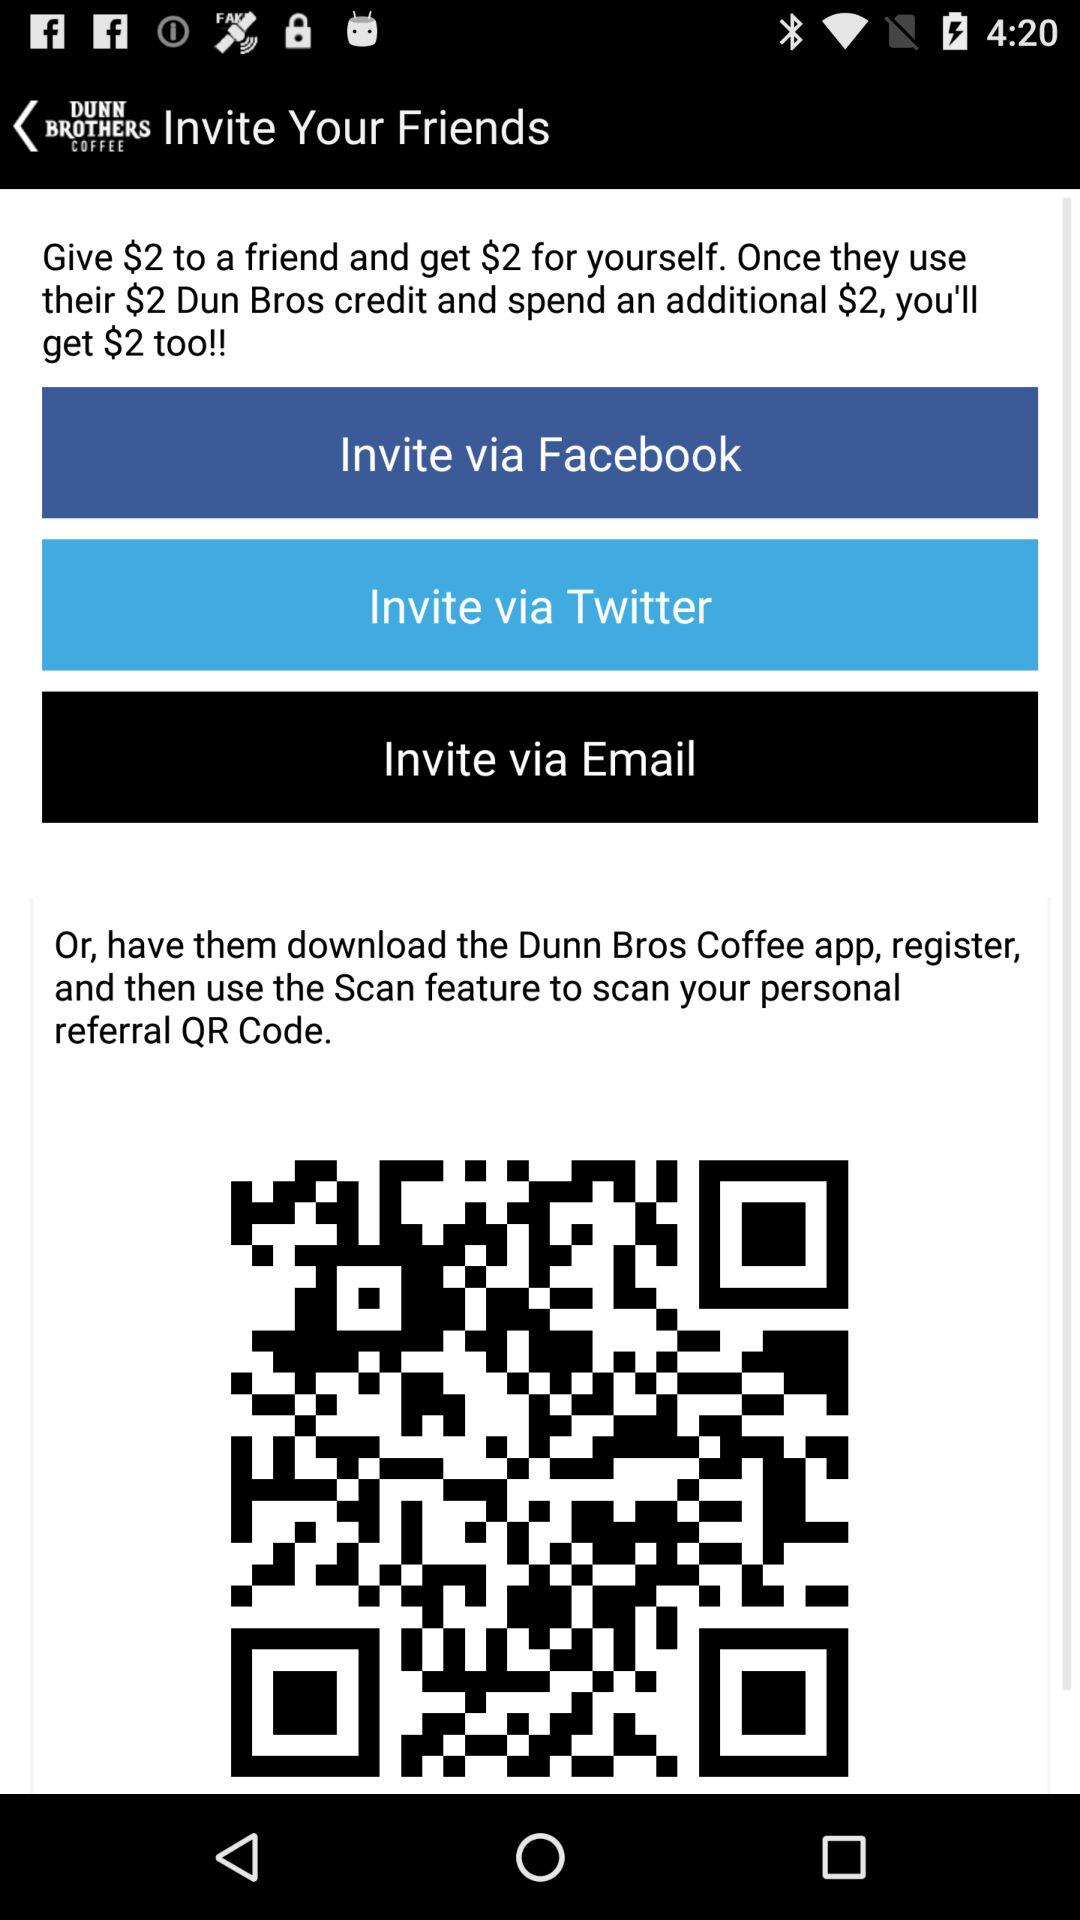What are the options for sending the invitation? The options for sending the invitation are "Facebook", "Twitter" and "Email". 